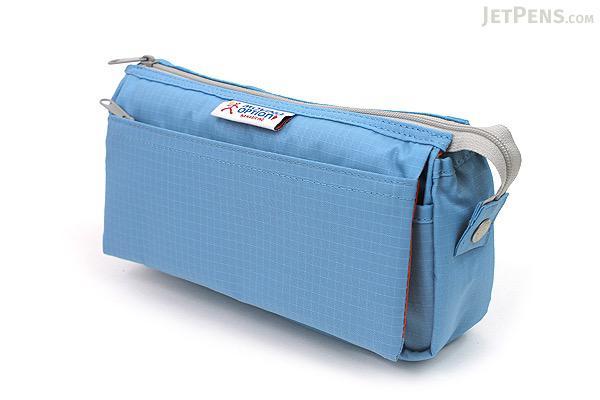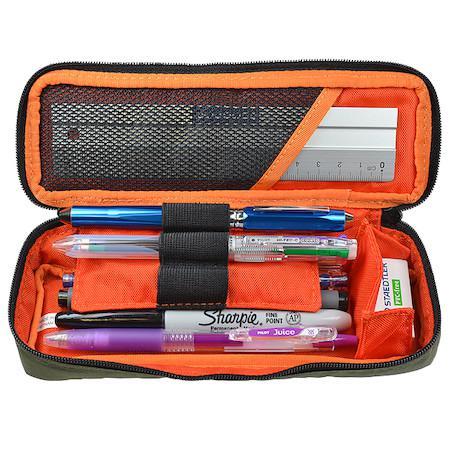The first image is the image on the left, the second image is the image on the right. Assess this claim about the two images: "An image shows just one pencil case, and it is solid sky blue in color.". Correct or not? Answer yes or no. Yes. The first image is the image on the left, the second image is the image on the right. For the images displayed, is the sentence "There is a single oblong, black rectangular case with no visible logo on it." factually correct? Answer yes or no. No. 